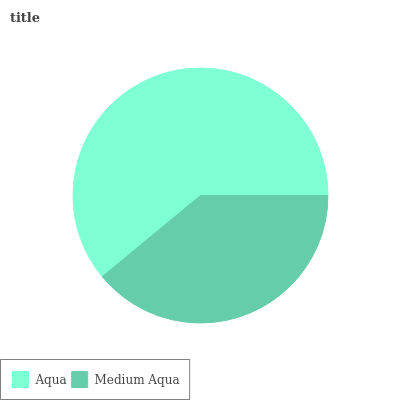Is Medium Aqua the minimum?
Answer yes or no. Yes. Is Aqua the maximum?
Answer yes or no. Yes. Is Medium Aqua the maximum?
Answer yes or no. No. Is Aqua greater than Medium Aqua?
Answer yes or no. Yes. Is Medium Aqua less than Aqua?
Answer yes or no. Yes. Is Medium Aqua greater than Aqua?
Answer yes or no. No. Is Aqua less than Medium Aqua?
Answer yes or no. No. Is Aqua the high median?
Answer yes or no. Yes. Is Medium Aqua the low median?
Answer yes or no. Yes. Is Medium Aqua the high median?
Answer yes or no. No. Is Aqua the low median?
Answer yes or no. No. 